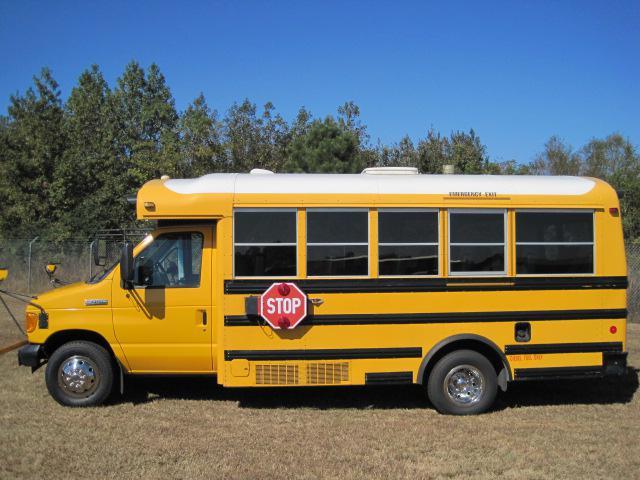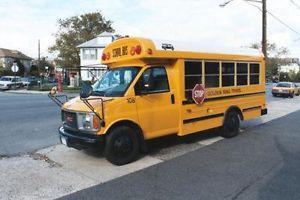The first image is the image on the left, the second image is the image on the right. Assess this claim about the two images: "Left and right images each contain one new-condition yellow bus with a sloped front instead of a flat front and no more than five passenger windows per side.". Correct or not? Answer yes or no. Yes. The first image is the image on the left, the second image is the image on the right. For the images displayed, is the sentence "Both buses are pointing to the right." factually correct? Answer yes or no. No. 